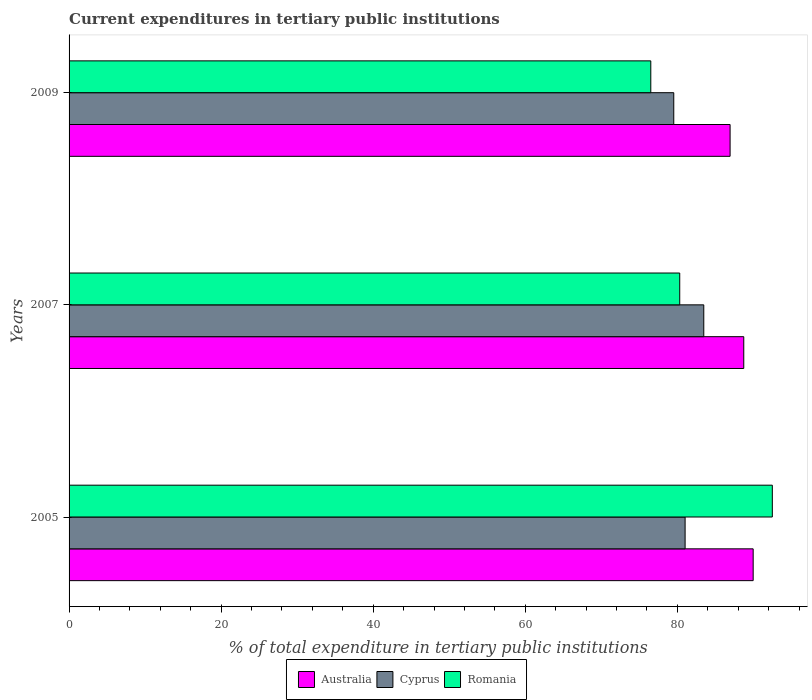Are the number of bars per tick equal to the number of legend labels?
Your answer should be very brief. Yes. How many bars are there on the 3rd tick from the top?
Keep it short and to the point. 3. How many bars are there on the 1st tick from the bottom?
Your answer should be very brief. 3. What is the label of the 1st group of bars from the top?
Ensure brevity in your answer.  2009. What is the current expenditures in tertiary public institutions in Cyprus in 2009?
Provide a succinct answer. 79.52. Across all years, what is the maximum current expenditures in tertiary public institutions in Romania?
Make the answer very short. 92.48. Across all years, what is the minimum current expenditures in tertiary public institutions in Cyprus?
Give a very brief answer. 79.52. What is the total current expenditures in tertiary public institutions in Australia in the graph?
Give a very brief answer. 265.62. What is the difference between the current expenditures in tertiary public institutions in Romania in 2005 and that in 2007?
Ensure brevity in your answer.  12.18. What is the difference between the current expenditures in tertiary public institutions in Australia in 2005 and the current expenditures in tertiary public institutions in Cyprus in 2007?
Your response must be concise. 6.5. What is the average current expenditures in tertiary public institutions in Romania per year?
Your answer should be compact. 83.1. In the year 2009, what is the difference between the current expenditures in tertiary public institutions in Cyprus and current expenditures in tertiary public institutions in Australia?
Provide a succinct answer. -7.41. What is the ratio of the current expenditures in tertiary public institutions in Australia in 2005 to that in 2009?
Give a very brief answer. 1.03. Is the difference between the current expenditures in tertiary public institutions in Cyprus in 2005 and 2009 greater than the difference between the current expenditures in tertiary public institutions in Australia in 2005 and 2009?
Make the answer very short. No. What is the difference between the highest and the second highest current expenditures in tertiary public institutions in Cyprus?
Make the answer very short. 2.45. What is the difference between the highest and the lowest current expenditures in tertiary public institutions in Australia?
Offer a terse response. 3.03. Is the sum of the current expenditures in tertiary public institutions in Australia in 2005 and 2009 greater than the maximum current expenditures in tertiary public institutions in Cyprus across all years?
Offer a terse response. Yes. What does the 1st bar from the top in 2009 represents?
Offer a terse response. Romania. What does the 3rd bar from the bottom in 2005 represents?
Offer a terse response. Romania. Is it the case that in every year, the sum of the current expenditures in tertiary public institutions in Romania and current expenditures in tertiary public institutions in Cyprus is greater than the current expenditures in tertiary public institutions in Australia?
Make the answer very short. Yes. How many bars are there?
Your answer should be compact. 9. Are all the bars in the graph horizontal?
Your response must be concise. Yes. How many years are there in the graph?
Give a very brief answer. 3. Are the values on the major ticks of X-axis written in scientific E-notation?
Offer a terse response. No. Does the graph contain grids?
Give a very brief answer. No. How many legend labels are there?
Your response must be concise. 3. How are the legend labels stacked?
Make the answer very short. Horizontal. What is the title of the graph?
Keep it short and to the point. Current expenditures in tertiary public institutions. What is the label or title of the X-axis?
Offer a terse response. % of total expenditure in tertiary public institutions. What is the % of total expenditure in tertiary public institutions in Australia in 2005?
Ensure brevity in your answer.  89.96. What is the % of total expenditure in tertiary public institutions of Cyprus in 2005?
Your response must be concise. 81.01. What is the % of total expenditure in tertiary public institutions in Romania in 2005?
Offer a terse response. 92.48. What is the % of total expenditure in tertiary public institutions of Australia in 2007?
Ensure brevity in your answer.  88.73. What is the % of total expenditure in tertiary public institutions of Cyprus in 2007?
Keep it short and to the point. 83.47. What is the % of total expenditure in tertiary public institutions in Romania in 2007?
Your answer should be compact. 80.31. What is the % of total expenditure in tertiary public institutions of Australia in 2009?
Keep it short and to the point. 86.93. What is the % of total expenditure in tertiary public institutions of Cyprus in 2009?
Provide a succinct answer. 79.52. What is the % of total expenditure in tertiary public institutions in Romania in 2009?
Offer a terse response. 76.5. Across all years, what is the maximum % of total expenditure in tertiary public institutions of Australia?
Provide a succinct answer. 89.96. Across all years, what is the maximum % of total expenditure in tertiary public institutions in Cyprus?
Offer a terse response. 83.47. Across all years, what is the maximum % of total expenditure in tertiary public institutions in Romania?
Offer a terse response. 92.48. Across all years, what is the minimum % of total expenditure in tertiary public institutions in Australia?
Ensure brevity in your answer.  86.93. Across all years, what is the minimum % of total expenditure in tertiary public institutions of Cyprus?
Provide a succinct answer. 79.52. Across all years, what is the minimum % of total expenditure in tertiary public institutions of Romania?
Offer a very short reply. 76.5. What is the total % of total expenditure in tertiary public institutions in Australia in the graph?
Give a very brief answer. 265.62. What is the total % of total expenditure in tertiary public institutions in Cyprus in the graph?
Your response must be concise. 244. What is the total % of total expenditure in tertiary public institutions in Romania in the graph?
Your answer should be very brief. 249.29. What is the difference between the % of total expenditure in tertiary public institutions of Australia in 2005 and that in 2007?
Your response must be concise. 1.24. What is the difference between the % of total expenditure in tertiary public institutions in Cyprus in 2005 and that in 2007?
Offer a terse response. -2.45. What is the difference between the % of total expenditure in tertiary public institutions of Romania in 2005 and that in 2007?
Offer a terse response. 12.18. What is the difference between the % of total expenditure in tertiary public institutions in Australia in 2005 and that in 2009?
Keep it short and to the point. 3.03. What is the difference between the % of total expenditure in tertiary public institutions of Cyprus in 2005 and that in 2009?
Your response must be concise. 1.49. What is the difference between the % of total expenditure in tertiary public institutions in Romania in 2005 and that in 2009?
Give a very brief answer. 15.98. What is the difference between the % of total expenditure in tertiary public institutions of Australia in 2007 and that in 2009?
Provide a short and direct response. 1.8. What is the difference between the % of total expenditure in tertiary public institutions in Cyprus in 2007 and that in 2009?
Offer a very short reply. 3.95. What is the difference between the % of total expenditure in tertiary public institutions in Romania in 2007 and that in 2009?
Provide a succinct answer. 3.81. What is the difference between the % of total expenditure in tertiary public institutions in Australia in 2005 and the % of total expenditure in tertiary public institutions in Cyprus in 2007?
Keep it short and to the point. 6.5. What is the difference between the % of total expenditure in tertiary public institutions in Australia in 2005 and the % of total expenditure in tertiary public institutions in Romania in 2007?
Make the answer very short. 9.66. What is the difference between the % of total expenditure in tertiary public institutions of Cyprus in 2005 and the % of total expenditure in tertiary public institutions of Romania in 2007?
Make the answer very short. 0.71. What is the difference between the % of total expenditure in tertiary public institutions in Australia in 2005 and the % of total expenditure in tertiary public institutions in Cyprus in 2009?
Provide a succinct answer. 10.44. What is the difference between the % of total expenditure in tertiary public institutions in Australia in 2005 and the % of total expenditure in tertiary public institutions in Romania in 2009?
Keep it short and to the point. 13.46. What is the difference between the % of total expenditure in tertiary public institutions in Cyprus in 2005 and the % of total expenditure in tertiary public institutions in Romania in 2009?
Your answer should be very brief. 4.51. What is the difference between the % of total expenditure in tertiary public institutions of Australia in 2007 and the % of total expenditure in tertiary public institutions of Cyprus in 2009?
Provide a short and direct response. 9.2. What is the difference between the % of total expenditure in tertiary public institutions in Australia in 2007 and the % of total expenditure in tertiary public institutions in Romania in 2009?
Provide a succinct answer. 12.22. What is the difference between the % of total expenditure in tertiary public institutions of Cyprus in 2007 and the % of total expenditure in tertiary public institutions of Romania in 2009?
Provide a succinct answer. 6.97. What is the average % of total expenditure in tertiary public institutions of Australia per year?
Give a very brief answer. 88.54. What is the average % of total expenditure in tertiary public institutions of Cyprus per year?
Your answer should be compact. 81.33. What is the average % of total expenditure in tertiary public institutions in Romania per year?
Your answer should be very brief. 83.1. In the year 2005, what is the difference between the % of total expenditure in tertiary public institutions of Australia and % of total expenditure in tertiary public institutions of Cyprus?
Make the answer very short. 8.95. In the year 2005, what is the difference between the % of total expenditure in tertiary public institutions in Australia and % of total expenditure in tertiary public institutions in Romania?
Make the answer very short. -2.52. In the year 2005, what is the difference between the % of total expenditure in tertiary public institutions in Cyprus and % of total expenditure in tertiary public institutions in Romania?
Provide a short and direct response. -11.47. In the year 2007, what is the difference between the % of total expenditure in tertiary public institutions of Australia and % of total expenditure in tertiary public institutions of Cyprus?
Your response must be concise. 5.26. In the year 2007, what is the difference between the % of total expenditure in tertiary public institutions in Australia and % of total expenditure in tertiary public institutions in Romania?
Your answer should be compact. 8.42. In the year 2007, what is the difference between the % of total expenditure in tertiary public institutions of Cyprus and % of total expenditure in tertiary public institutions of Romania?
Provide a succinct answer. 3.16. In the year 2009, what is the difference between the % of total expenditure in tertiary public institutions of Australia and % of total expenditure in tertiary public institutions of Cyprus?
Your answer should be very brief. 7.41. In the year 2009, what is the difference between the % of total expenditure in tertiary public institutions in Australia and % of total expenditure in tertiary public institutions in Romania?
Offer a very short reply. 10.43. In the year 2009, what is the difference between the % of total expenditure in tertiary public institutions of Cyprus and % of total expenditure in tertiary public institutions of Romania?
Your answer should be very brief. 3.02. What is the ratio of the % of total expenditure in tertiary public institutions of Australia in 2005 to that in 2007?
Provide a succinct answer. 1.01. What is the ratio of the % of total expenditure in tertiary public institutions of Cyprus in 2005 to that in 2007?
Ensure brevity in your answer.  0.97. What is the ratio of the % of total expenditure in tertiary public institutions in Romania in 2005 to that in 2007?
Give a very brief answer. 1.15. What is the ratio of the % of total expenditure in tertiary public institutions in Australia in 2005 to that in 2009?
Your answer should be compact. 1.03. What is the ratio of the % of total expenditure in tertiary public institutions of Cyprus in 2005 to that in 2009?
Offer a very short reply. 1.02. What is the ratio of the % of total expenditure in tertiary public institutions of Romania in 2005 to that in 2009?
Keep it short and to the point. 1.21. What is the ratio of the % of total expenditure in tertiary public institutions of Australia in 2007 to that in 2009?
Provide a short and direct response. 1.02. What is the ratio of the % of total expenditure in tertiary public institutions in Cyprus in 2007 to that in 2009?
Your answer should be compact. 1.05. What is the ratio of the % of total expenditure in tertiary public institutions in Romania in 2007 to that in 2009?
Ensure brevity in your answer.  1.05. What is the difference between the highest and the second highest % of total expenditure in tertiary public institutions of Australia?
Provide a succinct answer. 1.24. What is the difference between the highest and the second highest % of total expenditure in tertiary public institutions in Cyprus?
Give a very brief answer. 2.45. What is the difference between the highest and the second highest % of total expenditure in tertiary public institutions of Romania?
Your answer should be compact. 12.18. What is the difference between the highest and the lowest % of total expenditure in tertiary public institutions in Australia?
Ensure brevity in your answer.  3.03. What is the difference between the highest and the lowest % of total expenditure in tertiary public institutions of Cyprus?
Provide a succinct answer. 3.95. What is the difference between the highest and the lowest % of total expenditure in tertiary public institutions of Romania?
Your answer should be very brief. 15.98. 